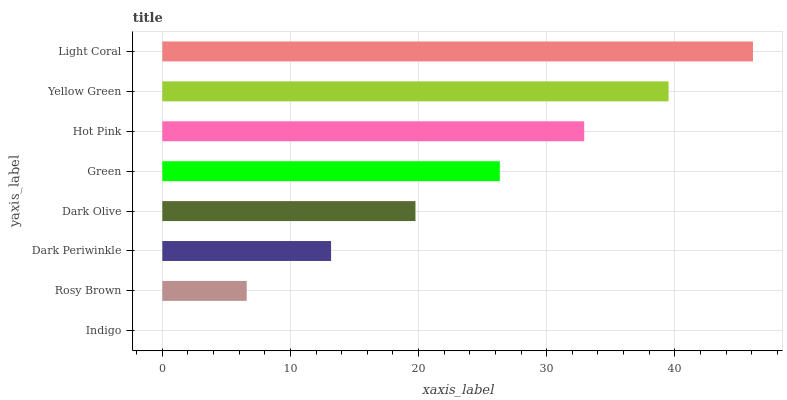Is Indigo the minimum?
Answer yes or no. Yes. Is Light Coral the maximum?
Answer yes or no. Yes. Is Rosy Brown the minimum?
Answer yes or no. No. Is Rosy Brown the maximum?
Answer yes or no. No. Is Rosy Brown greater than Indigo?
Answer yes or no. Yes. Is Indigo less than Rosy Brown?
Answer yes or no. Yes. Is Indigo greater than Rosy Brown?
Answer yes or no. No. Is Rosy Brown less than Indigo?
Answer yes or no. No. Is Green the high median?
Answer yes or no. Yes. Is Dark Olive the low median?
Answer yes or no. Yes. Is Dark Olive the high median?
Answer yes or no. No. Is Light Coral the low median?
Answer yes or no. No. 